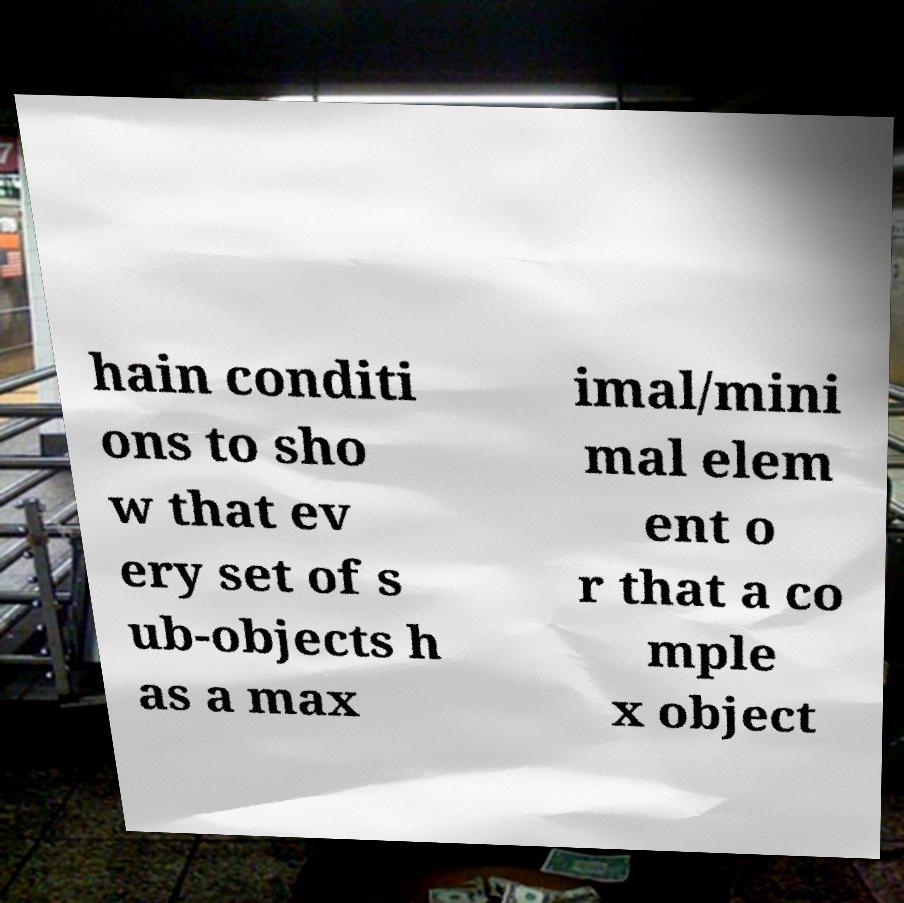Can you read and provide the text displayed in the image?This photo seems to have some interesting text. Can you extract and type it out for me? hain conditi ons to sho w that ev ery set of s ub-objects h as a max imal/mini mal elem ent o r that a co mple x object 